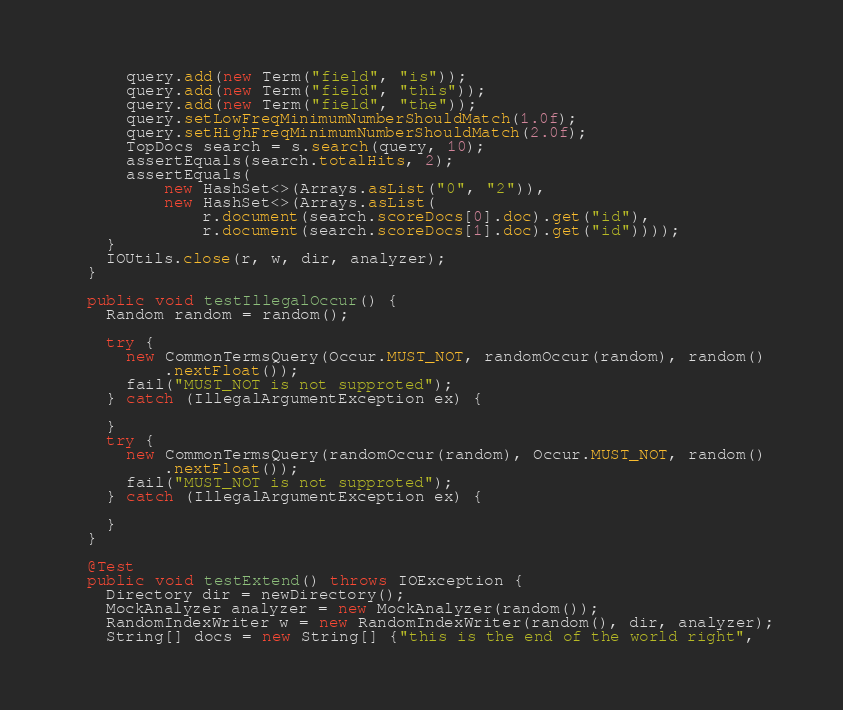Convert code to text. <code><loc_0><loc_0><loc_500><loc_500><_Java_>      query.add(new Term("field", "is"));
      query.add(new Term("field", "this"));
      query.add(new Term("field", "the"));
      query.setLowFreqMinimumNumberShouldMatch(1.0f);
      query.setHighFreqMinimumNumberShouldMatch(2.0f);
      TopDocs search = s.search(query, 10);
      assertEquals(search.totalHits, 2);
      assertEquals(
          new HashSet<>(Arrays.asList("0", "2")),
          new HashSet<>(Arrays.asList(
              r.document(search.scoreDocs[0].doc).get("id"),
              r.document(search.scoreDocs[1].doc).get("id"))));
    }
    IOUtils.close(r, w, dir, analyzer);
  }
  
  public void testIllegalOccur() {
    Random random = random();
    
    try {
      new CommonTermsQuery(Occur.MUST_NOT, randomOccur(random), random()
          .nextFloat());
      fail("MUST_NOT is not supproted");
    } catch (IllegalArgumentException ex) {
      
    }
    try {
      new CommonTermsQuery(randomOccur(random), Occur.MUST_NOT, random()
          .nextFloat());
      fail("MUST_NOT is not supproted");
    } catch (IllegalArgumentException ex) {
      
    }
  }

  @Test
  public void testExtend() throws IOException {
    Directory dir = newDirectory();
    MockAnalyzer analyzer = new MockAnalyzer(random());
    RandomIndexWriter w = new RandomIndexWriter(random(), dir, analyzer);
    String[] docs = new String[] {"this is the end of the world right",</code> 